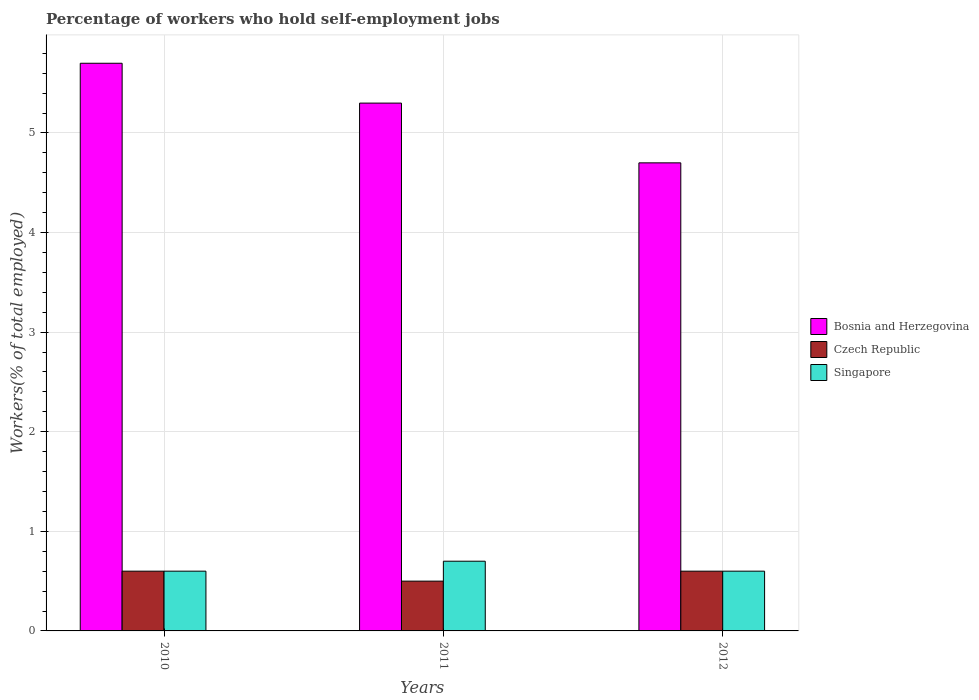How many groups of bars are there?
Your response must be concise. 3. Are the number of bars per tick equal to the number of legend labels?
Your response must be concise. Yes. In how many cases, is the number of bars for a given year not equal to the number of legend labels?
Your answer should be compact. 0. What is the percentage of self-employed workers in Bosnia and Herzegovina in 2011?
Give a very brief answer. 5.3. Across all years, what is the maximum percentage of self-employed workers in Bosnia and Herzegovina?
Ensure brevity in your answer.  5.7. Across all years, what is the minimum percentage of self-employed workers in Czech Republic?
Give a very brief answer. 0.5. What is the total percentage of self-employed workers in Singapore in the graph?
Your answer should be compact. 1.9. What is the difference between the percentage of self-employed workers in Czech Republic in 2011 and the percentage of self-employed workers in Singapore in 2012?
Make the answer very short. -0.1. What is the average percentage of self-employed workers in Singapore per year?
Give a very brief answer. 0.63. In the year 2010, what is the difference between the percentage of self-employed workers in Singapore and percentage of self-employed workers in Bosnia and Herzegovina?
Ensure brevity in your answer.  -5.1. What is the ratio of the percentage of self-employed workers in Czech Republic in 2010 to that in 2011?
Offer a very short reply. 1.2. Is the percentage of self-employed workers in Czech Republic in 2011 less than that in 2012?
Provide a succinct answer. Yes. Is the difference between the percentage of self-employed workers in Singapore in 2011 and 2012 greater than the difference between the percentage of self-employed workers in Bosnia and Herzegovina in 2011 and 2012?
Provide a succinct answer. No. What is the difference between the highest and the lowest percentage of self-employed workers in Singapore?
Provide a short and direct response. 0.1. In how many years, is the percentage of self-employed workers in Bosnia and Herzegovina greater than the average percentage of self-employed workers in Bosnia and Herzegovina taken over all years?
Provide a succinct answer. 2. Is the sum of the percentage of self-employed workers in Bosnia and Herzegovina in 2010 and 2012 greater than the maximum percentage of self-employed workers in Czech Republic across all years?
Ensure brevity in your answer.  Yes. What does the 3rd bar from the left in 2010 represents?
Your answer should be compact. Singapore. What does the 3rd bar from the right in 2010 represents?
Offer a very short reply. Bosnia and Herzegovina. How many bars are there?
Offer a terse response. 9. Are all the bars in the graph horizontal?
Provide a short and direct response. No. Are the values on the major ticks of Y-axis written in scientific E-notation?
Ensure brevity in your answer.  No. Does the graph contain any zero values?
Your answer should be very brief. No. How many legend labels are there?
Your response must be concise. 3. What is the title of the graph?
Your answer should be very brief. Percentage of workers who hold self-employment jobs. Does "San Marino" appear as one of the legend labels in the graph?
Your response must be concise. No. What is the label or title of the Y-axis?
Provide a short and direct response. Workers(% of total employed). What is the Workers(% of total employed) in Bosnia and Herzegovina in 2010?
Keep it short and to the point. 5.7. What is the Workers(% of total employed) of Czech Republic in 2010?
Make the answer very short. 0.6. What is the Workers(% of total employed) of Singapore in 2010?
Make the answer very short. 0.6. What is the Workers(% of total employed) of Bosnia and Herzegovina in 2011?
Your answer should be compact. 5.3. What is the Workers(% of total employed) of Czech Republic in 2011?
Make the answer very short. 0.5. What is the Workers(% of total employed) in Singapore in 2011?
Your answer should be very brief. 0.7. What is the Workers(% of total employed) of Bosnia and Herzegovina in 2012?
Keep it short and to the point. 4.7. What is the Workers(% of total employed) of Czech Republic in 2012?
Keep it short and to the point. 0.6. What is the Workers(% of total employed) in Singapore in 2012?
Your response must be concise. 0.6. Across all years, what is the maximum Workers(% of total employed) in Bosnia and Herzegovina?
Your response must be concise. 5.7. Across all years, what is the maximum Workers(% of total employed) of Czech Republic?
Offer a terse response. 0.6. Across all years, what is the maximum Workers(% of total employed) of Singapore?
Ensure brevity in your answer.  0.7. Across all years, what is the minimum Workers(% of total employed) of Bosnia and Herzegovina?
Offer a terse response. 4.7. Across all years, what is the minimum Workers(% of total employed) in Singapore?
Provide a succinct answer. 0.6. What is the total Workers(% of total employed) of Bosnia and Herzegovina in the graph?
Your response must be concise. 15.7. What is the total Workers(% of total employed) in Singapore in the graph?
Offer a very short reply. 1.9. What is the difference between the Workers(% of total employed) in Bosnia and Herzegovina in 2010 and that in 2011?
Make the answer very short. 0.4. What is the difference between the Workers(% of total employed) in Czech Republic in 2010 and that in 2011?
Provide a short and direct response. 0.1. What is the difference between the Workers(% of total employed) in Bosnia and Herzegovina in 2010 and that in 2012?
Offer a terse response. 1. What is the difference between the Workers(% of total employed) in Czech Republic in 2011 and that in 2012?
Offer a terse response. -0.1. What is the difference between the Workers(% of total employed) of Singapore in 2011 and that in 2012?
Keep it short and to the point. 0.1. What is the difference between the Workers(% of total employed) of Bosnia and Herzegovina in 2010 and the Workers(% of total employed) of Singapore in 2011?
Your answer should be compact. 5. What is the difference between the Workers(% of total employed) of Czech Republic in 2010 and the Workers(% of total employed) of Singapore in 2011?
Offer a very short reply. -0.1. What is the difference between the Workers(% of total employed) in Bosnia and Herzegovina in 2010 and the Workers(% of total employed) in Singapore in 2012?
Your answer should be compact. 5.1. What is the difference between the Workers(% of total employed) of Bosnia and Herzegovina in 2011 and the Workers(% of total employed) of Czech Republic in 2012?
Give a very brief answer. 4.7. What is the average Workers(% of total employed) of Bosnia and Herzegovina per year?
Keep it short and to the point. 5.23. What is the average Workers(% of total employed) in Czech Republic per year?
Give a very brief answer. 0.57. What is the average Workers(% of total employed) in Singapore per year?
Ensure brevity in your answer.  0.63. In the year 2010, what is the difference between the Workers(% of total employed) in Bosnia and Herzegovina and Workers(% of total employed) in Singapore?
Offer a terse response. 5.1. In the year 2011, what is the difference between the Workers(% of total employed) of Bosnia and Herzegovina and Workers(% of total employed) of Singapore?
Your answer should be compact. 4.6. In the year 2012, what is the difference between the Workers(% of total employed) in Bosnia and Herzegovina and Workers(% of total employed) in Czech Republic?
Offer a terse response. 4.1. In the year 2012, what is the difference between the Workers(% of total employed) in Bosnia and Herzegovina and Workers(% of total employed) in Singapore?
Your answer should be compact. 4.1. What is the ratio of the Workers(% of total employed) of Bosnia and Herzegovina in 2010 to that in 2011?
Offer a terse response. 1.08. What is the ratio of the Workers(% of total employed) of Czech Republic in 2010 to that in 2011?
Give a very brief answer. 1.2. What is the ratio of the Workers(% of total employed) of Bosnia and Herzegovina in 2010 to that in 2012?
Provide a short and direct response. 1.21. What is the ratio of the Workers(% of total employed) in Czech Republic in 2010 to that in 2012?
Keep it short and to the point. 1. What is the ratio of the Workers(% of total employed) in Singapore in 2010 to that in 2012?
Provide a succinct answer. 1. What is the ratio of the Workers(% of total employed) of Bosnia and Herzegovina in 2011 to that in 2012?
Offer a very short reply. 1.13. What is the ratio of the Workers(% of total employed) of Singapore in 2011 to that in 2012?
Provide a short and direct response. 1.17. What is the difference between the highest and the lowest Workers(% of total employed) of Bosnia and Herzegovina?
Offer a terse response. 1. What is the difference between the highest and the lowest Workers(% of total employed) in Czech Republic?
Offer a very short reply. 0.1. 